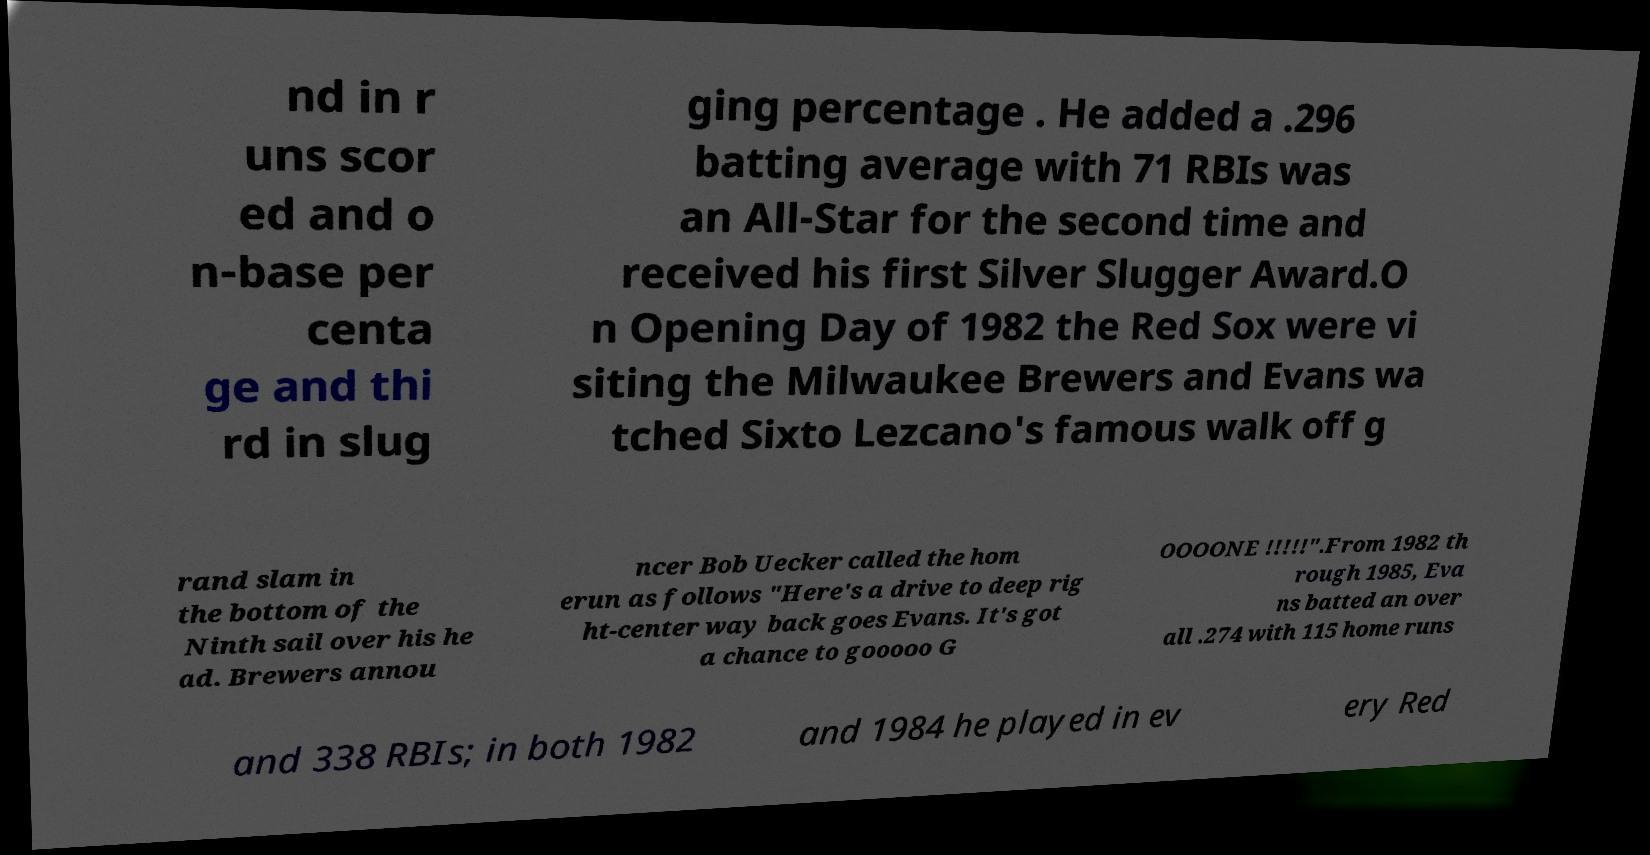Could you assist in decoding the text presented in this image and type it out clearly? nd in r uns scor ed and o n-base per centa ge and thi rd in slug ging percentage . He added a .296 batting average with 71 RBIs was an All-Star for the second time and received his first Silver Slugger Award.O n Opening Day of 1982 the Red Sox were vi siting the Milwaukee Brewers and Evans wa tched Sixto Lezcano's famous walk off g rand slam in the bottom of the Ninth sail over his he ad. Brewers annou ncer Bob Uecker called the hom erun as follows "Here's a drive to deep rig ht-center way back goes Evans. It's got a chance to gooooo G OOOONE !!!!!".From 1982 th rough 1985, Eva ns batted an over all .274 with 115 home runs and 338 RBIs; in both 1982 and 1984 he played in ev ery Red 